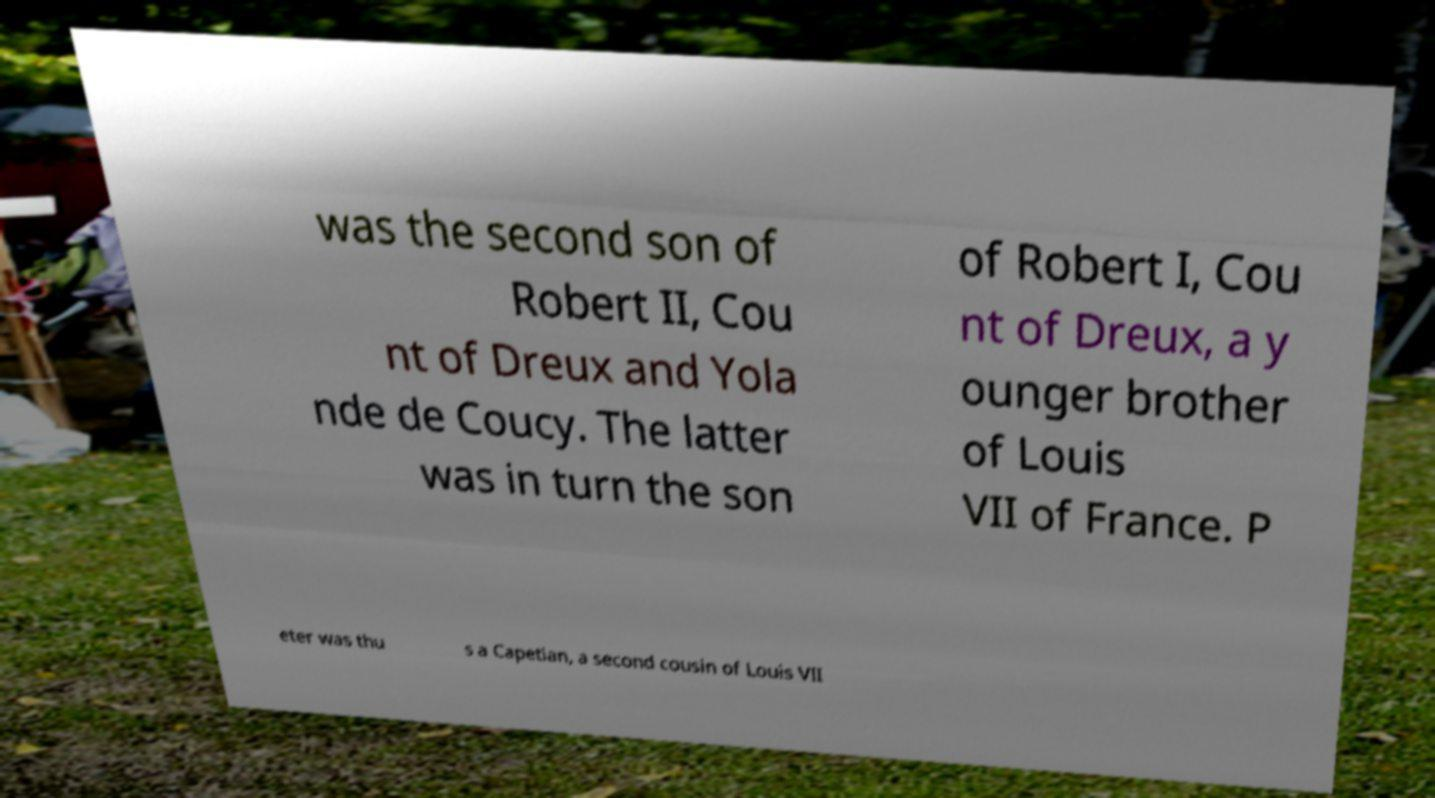For documentation purposes, I need the text within this image transcribed. Could you provide that? was the second son of Robert II, Cou nt of Dreux and Yola nde de Coucy. The latter was in turn the son of Robert I, Cou nt of Dreux, a y ounger brother of Louis VII of France. P eter was thu s a Capetian, a second cousin of Louis VII 